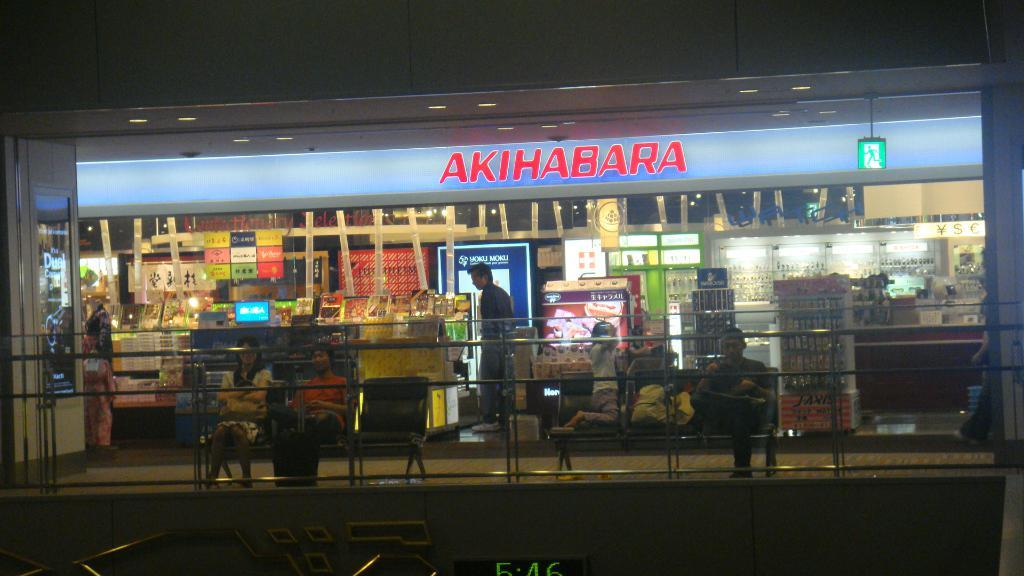<image>
Render a clear and concise summary of the photo. A store front has the word Akihabara on the top. 